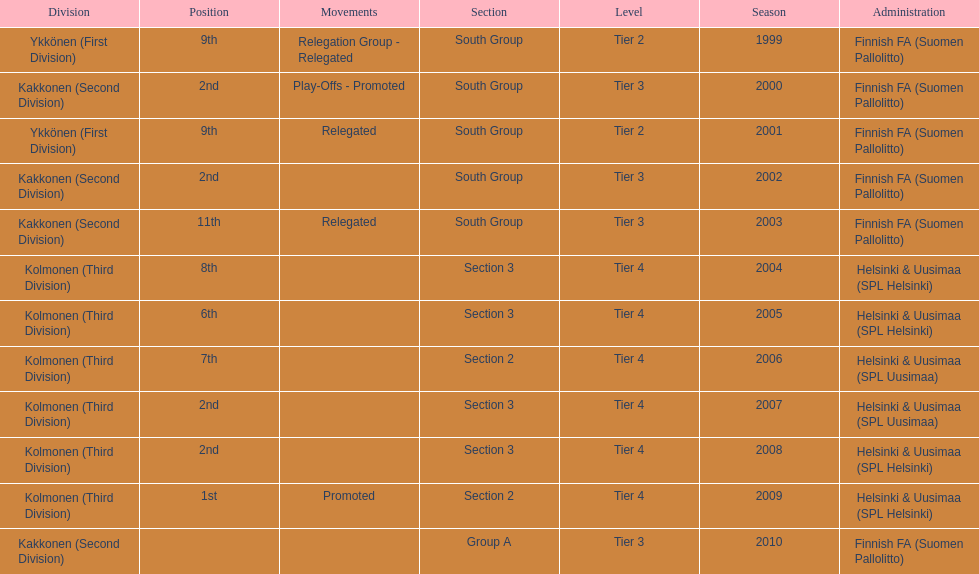Which administration has the least amount of division? Helsinki & Uusimaa (SPL Helsinki). 